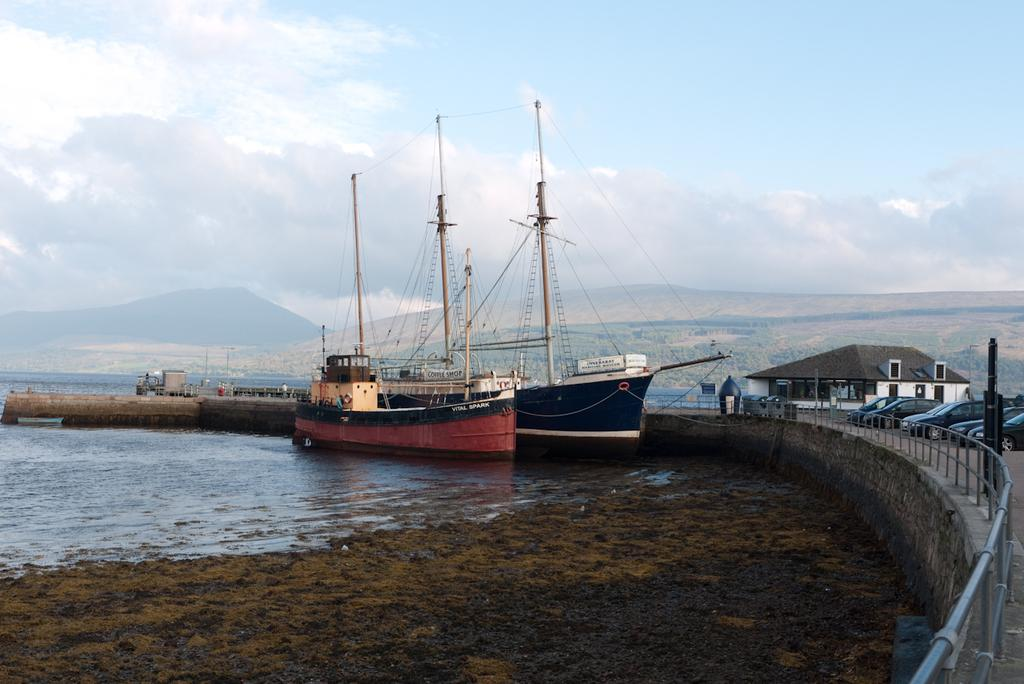What can be seen floating on the water in the image? There are two ships in the water. What type of terrain is visible in the image? There is mud visible in the image. What type of transportation can be seen in the image? There are vehicles in the image. What type of structure can be seen in the image? There are boards in the image. What is the person in the image doing? There is a person on a bridge in the image. What type of support structures can be seen in the image? There are poles in the image. What type of man-made structure can be seen in the image? There is a building in the image. What type of natural feature can be seen in the image? There are mountains in the image. What is visible in the sky in the image? There are clouds in the sky. Where is the goose in the image? There is no goose present in the image. What type of clothing is the father wearing in the image? There is no father present in the image. 